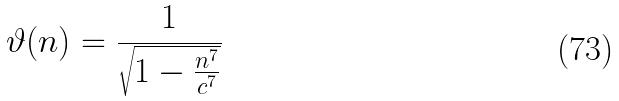<formula> <loc_0><loc_0><loc_500><loc_500>\vartheta ( n ) = \frac { 1 } { \sqrt { 1 - \frac { n ^ { 7 } } { c ^ { 7 } } } }</formula> 